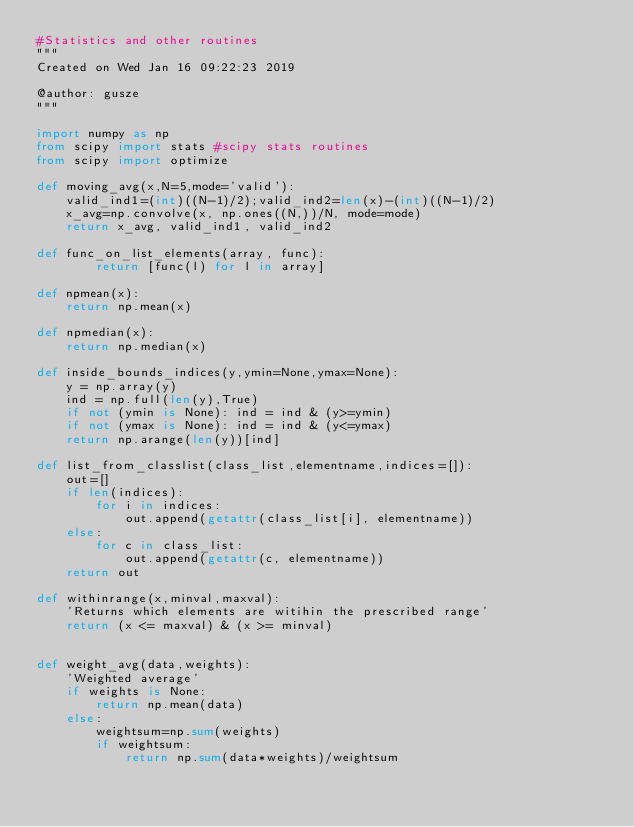<code> <loc_0><loc_0><loc_500><loc_500><_Python_>#Statistics and other routines
"""
Created on Wed Jan 16 09:22:23 2019

@author: gusze
"""

import numpy as np
from scipy import stats #scipy stats routines
from scipy import optimize

def moving_avg(x,N=5,mode='valid'):
    valid_ind1=(int)((N-1)/2);valid_ind2=len(x)-(int)((N-1)/2)
    x_avg=np.convolve(x, np.ones((N,))/N, mode=mode)
    return x_avg, valid_ind1, valid_ind2

def func_on_list_elements(array, func):
        return [func(l) for l in array]

def npmean(x):
    return np.mean(x)

def npmedian(x):
    return np.median(x)

def inside_bounds_indices(y,ymin=None,ymax=None):
    y = np.array(y)
    ind = np.full(len(y),True)
    if not (ymin is None): ind = ind & (y>=ymin)
    if not (ymax is None): ind = ind & (y<=ymax)
    return np.arange(len(y))[ind] 

def list_from_classlist(class_list,elementname,indices=[]):
    out=[]
    if len(indices):
        for i in indices:
            out.append(getattr(class_list[i], elementname))
    else:
        for c in class_list:
            out.append(getattr(c, elementname))
    return out

def withinrange(x,minval,maxval):
    'Returns which elements are witihin the prescribed range'
    return (x <= maxval) & (x >= minval)


def weight_avg(data,weights):
    'Weighted average'
    if weights is None:
        return np.mean(data)
    else:
        weightsum=np.sum(weights)
        if weightsum:
            return np.sum(data*weights)/weightsum</code> 